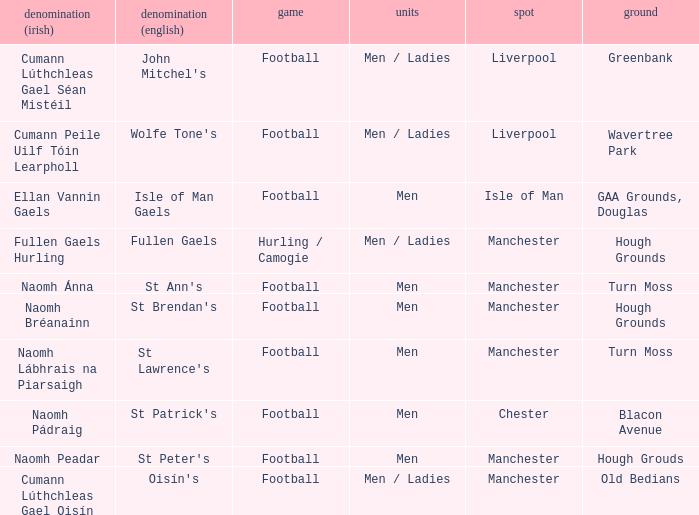What is the Location of the Old Bedians Pitch? Manchester. Write the full table. {'header': ['denomination (irish)', 'denomination (english)', 'game', 'units', 'spot', 'ground'], 'rows': [['Cumann Lúthchleas Gael Séan Mistéil', "John Mitchel's", 'Football', 'Men / Ladies', 'Liverpool', 'Greenbank'], ['Cumann Peile Uilf Tóin Learpholl', "Wolfe Tone's", 'Football', 'Men / Ladies', 'Liverpool', 'Wavertree Park'], ['Ellan Vannin Gaels', 'Isle of Man Gaels', 'Football', 'Men', 'Isle of Man', 'GAA Grounds, Douglas'], ['Fullen Gaels Hurling', 'Fullen Gaels', 'Hurling / Camogie', 'Men / Ladies', 'Manchester', 'Hough Grounds'], ['Naomh Ánna', "St Ann's", 'Football', 'Men', 'Manchester', 'Turn Moss'], ['Naomh Bréanainn', "St Brendan's", 'Football', 'Men', 'Manchester', 'Hough Grounds'], ['Naomh Lábhrais na Piarsaigh', "St Lawrence's", 'Football', 'Men', 'Manchester', 'Turn Moss'], ['Naomh Pádraig', "St Patrick's", 'Football', 'Men', 'Chester', 'Blacon Avenue'], ['Naomh Peadar', "St Peter's", 'Football', 'Men', 'Manchester', 'Hough Grouds'], ['Cumann Lúthchleas Gael Oisín', "Oisín's", 'Football', 'Men / Ladies', 'Manchester', 'Old Bedians']]} 